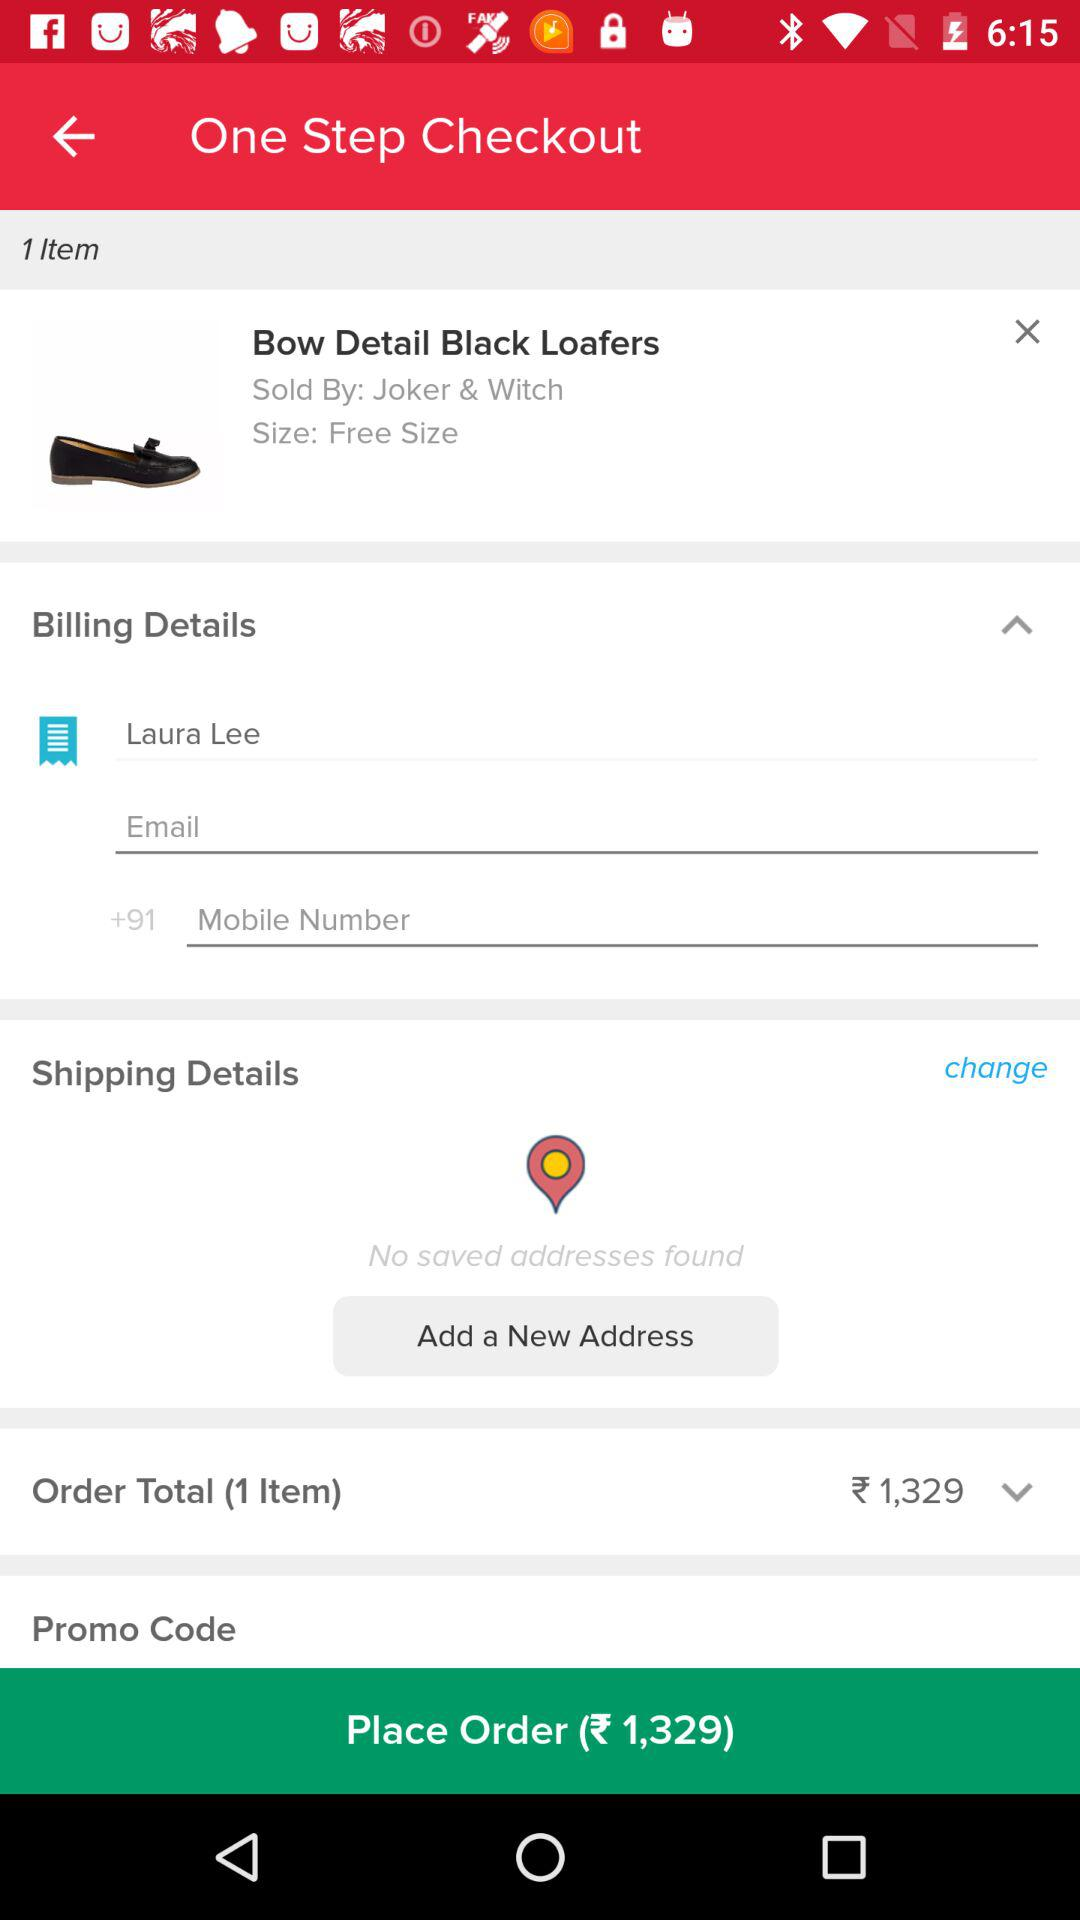How much does the order total?
Answer the question using a single word or phrase. 1,329 